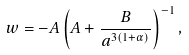<formula> <loc_0><loc_0><loc_500><loc_500>w = - A \left ( A + \frac { B } { a ^ { 3 ( 1 + \alpha ) } } \right ) ^ { - 1 } ,</formula> 